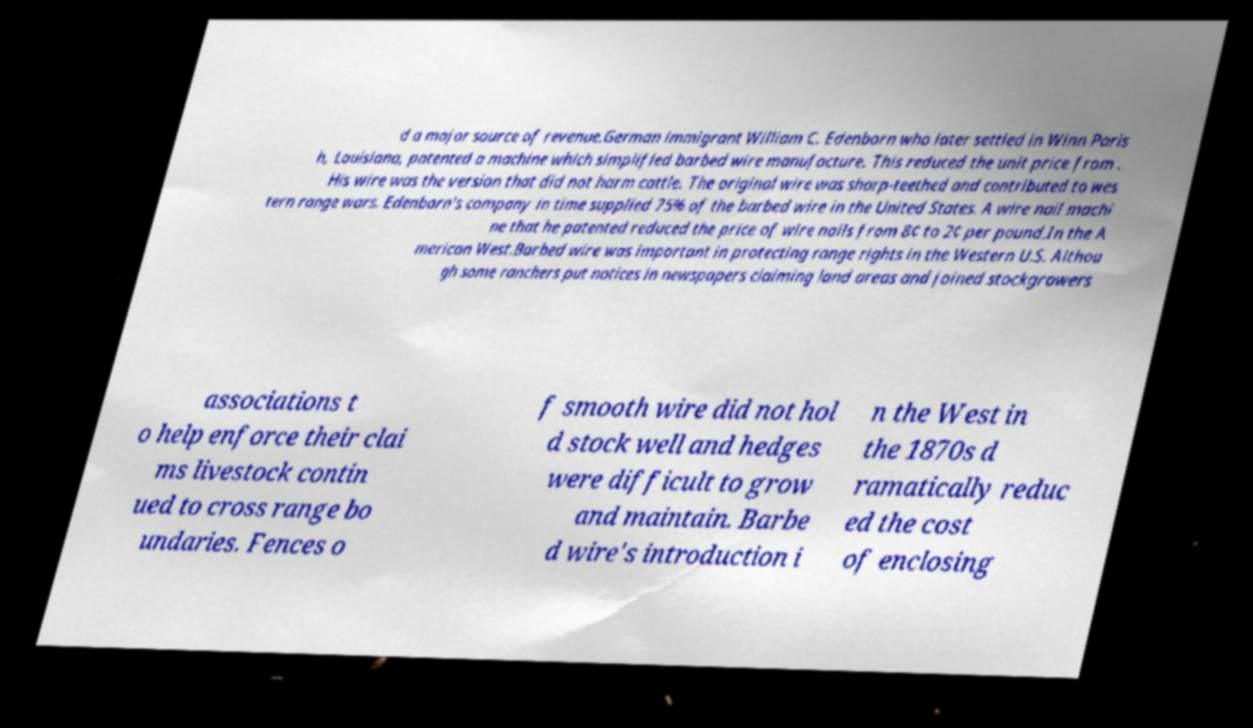Could you extract and type out the text from this image? d a major source of revenue.German immigrant William C. Edenborn who later settled in Winn Paris h, Louisiana, patented a machine which simplified barbed wire manufacture. This reduced the unit price from . His wire was the version that did not harm cattle. The original wire was sharp-teethed and contributed to wes tern range wars. Edenborn's company in time supplied 75% of the barbed wire in the United States. A wire nail machi ne that he patented reduced the price of wire nails from 8¢ to 2¢ per pound.In the A merican West.Barbed wire was important in protecting range rights in the Western U.S. Althou gh some ranchers put notices in newspapers claiming land areas and joined stockgrowers associations t o help enforce their clai ms livestock contin ued to cross range bo undaries. Fences o f smooth wire did not hol d stock well and hedges were difficult to grow and maintain. Barbe d wire's introduction i n the West in the 1870s d ramatically reduc ed the cost of enclosing 